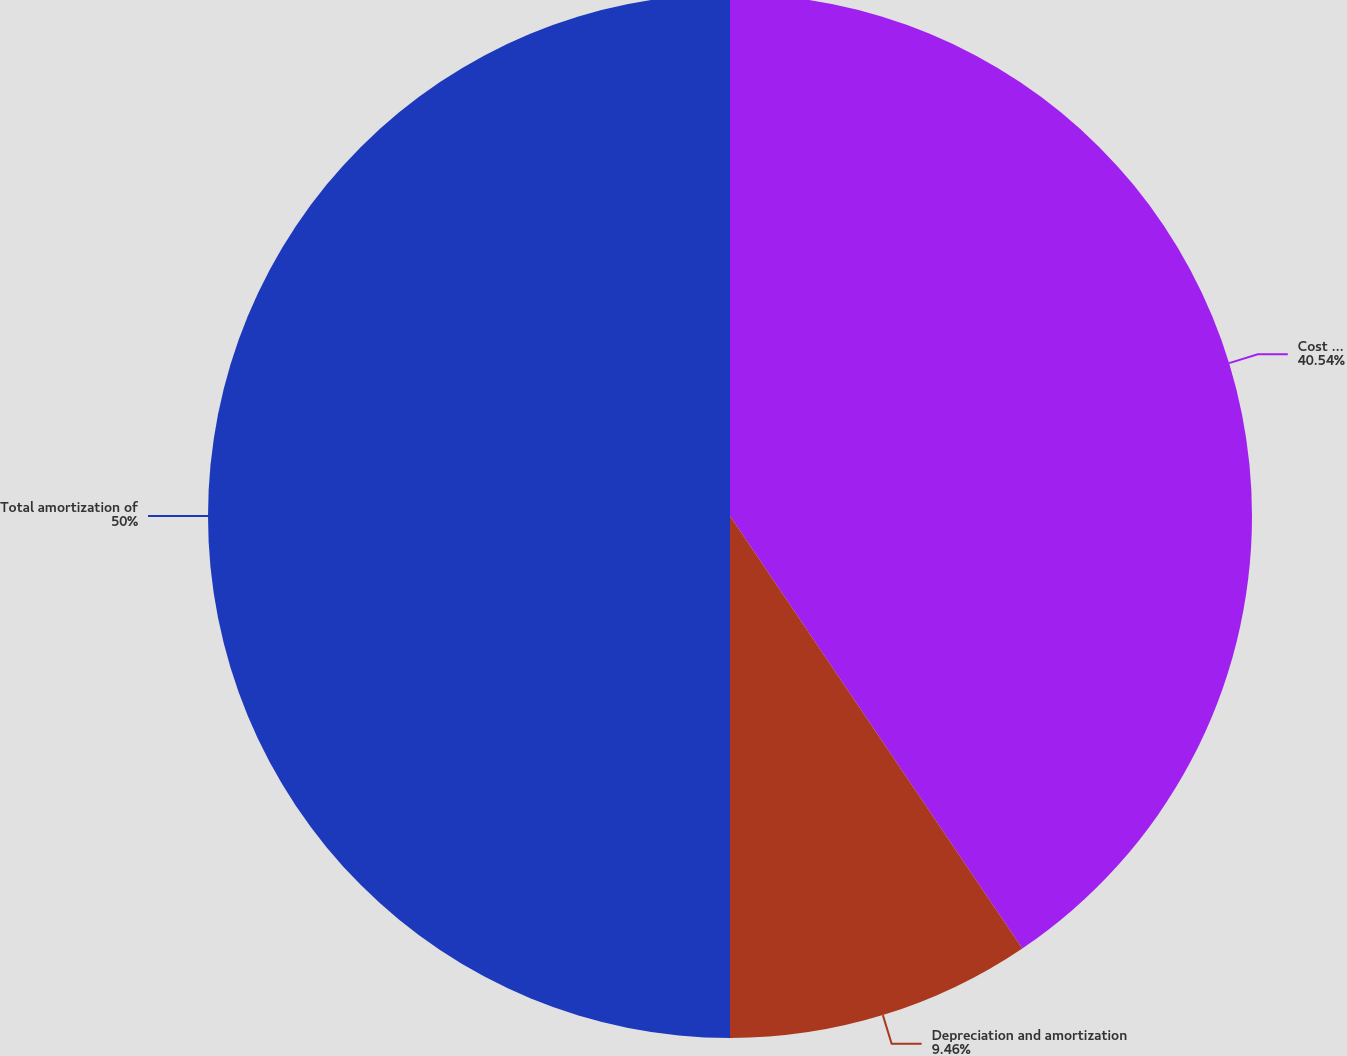Convert chart to OTSL. <chart><loc_0><loc_0><loc_500><loc_500><pie_chart><fcel>Cost of goods sold - product<fcel>Depreciation and amortization<fcel>Total amortization of<nl><fcel>40.54%<fcel>9.46%<fcel>50.0%<nl></chart> 